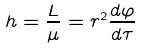<formula> <loc_0><loc_0><loc_500><loc_500>h = \frac { L } { \mu } = r ^ { 2 } \frac { d \varphi } { d \tau }</formula> 